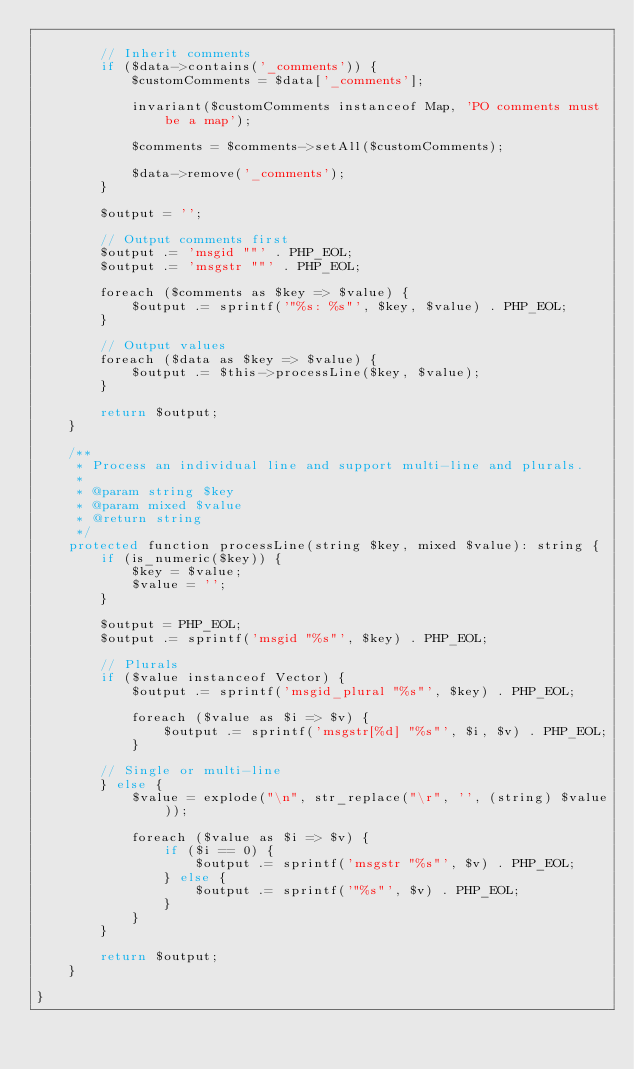<code> <loc_0><loc_0><loc_500><loc_500><_C++_>
        // Inherit comments
        if ($data->contains('_comments')) {
            $customComments = $data['_comments'];

            invariant($customComments instanceof Map, 'PO comments must be a map');

            $comments = $comments->setAll($customComments);

            $data->remove('_comments');
        }

        $output = '';

        // Output comments first
        $output .= 'msgid ""' . PHP_EOL;
        $output .= 'msgstr ""' . PHP_EOL;

        foreach ($comments as $key => $value) {
            $output .= sprintf('"%s: %s"', $key, $value) . PHP_EOL;
        }

        // Output values
        foreach ($data as $key => $value) {
            $output .= $this->processLine($key, $value);
        }

        return $output;
    }

    /**
     * Process an individual line and support multi-line and plurals.
     *
     * @param string $key
     * @param mixed $value
     * @return string
     */
    protected function processLine(string $key, mixed $value): string {
        if (is_numeric($key)) {
            $key = $value;
            $value = '';
        }

        $output = PHP_EOL;
        $output .= sprintf('msgid "%s"', $key) . PHP_EOL;

        // Plurals
        if ($value instanceof Vector) {
            $output .= sprintf('msgid_plural "%s"', $key) . PHP_EOL;

            foreach ($value as $i => $v) {
                $output .= sprintf('msgstr[%d] "%s"', $i, $v) . PHP_EOL;
            }

        // Single or multi-line
        } else {
            $value = explode("\n", str_replace("\r", '', (string) $value));

            foreach ($value as $i => $v) {
                if ($i == 0) {
                    $output .= sprintf('msgstr "%s"', $v) . PHP_EOL;
                } else {
                    $output .= sprintf('"%s"', $v) . PHP_EOL;
                }
            }
        }

        return $output;
    }

}
</code> 